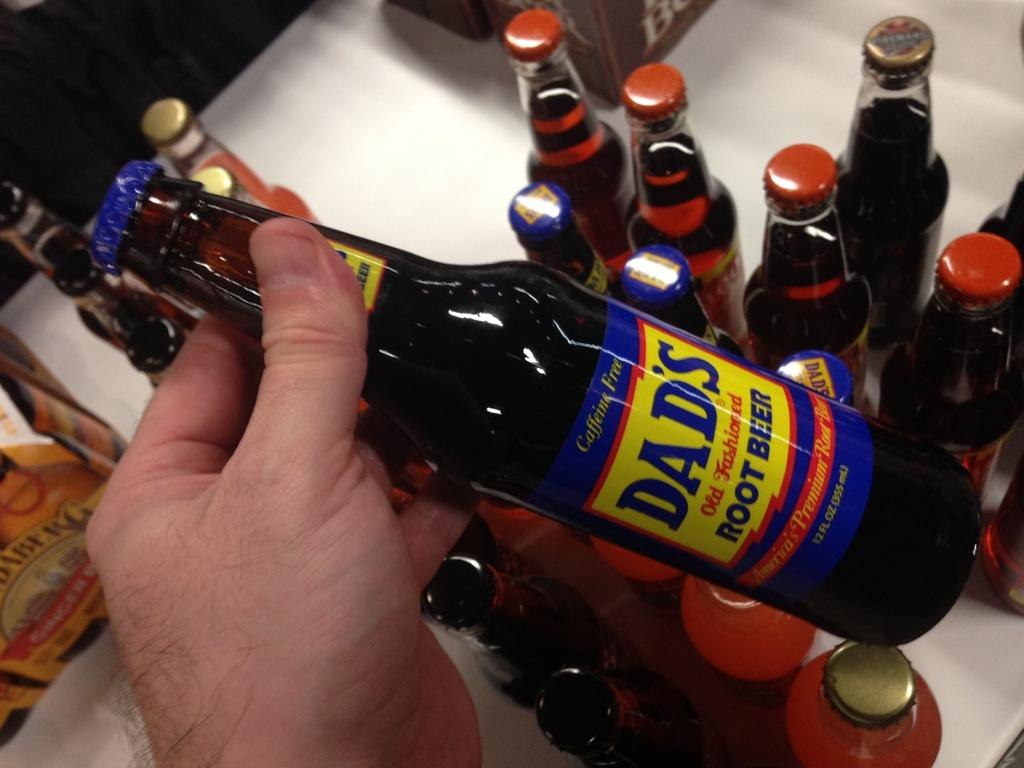<image>
Offer a succinct explanation of the picture presented. A bunch of bottles are on a table with  bottle of Dad' root beer being held up. 